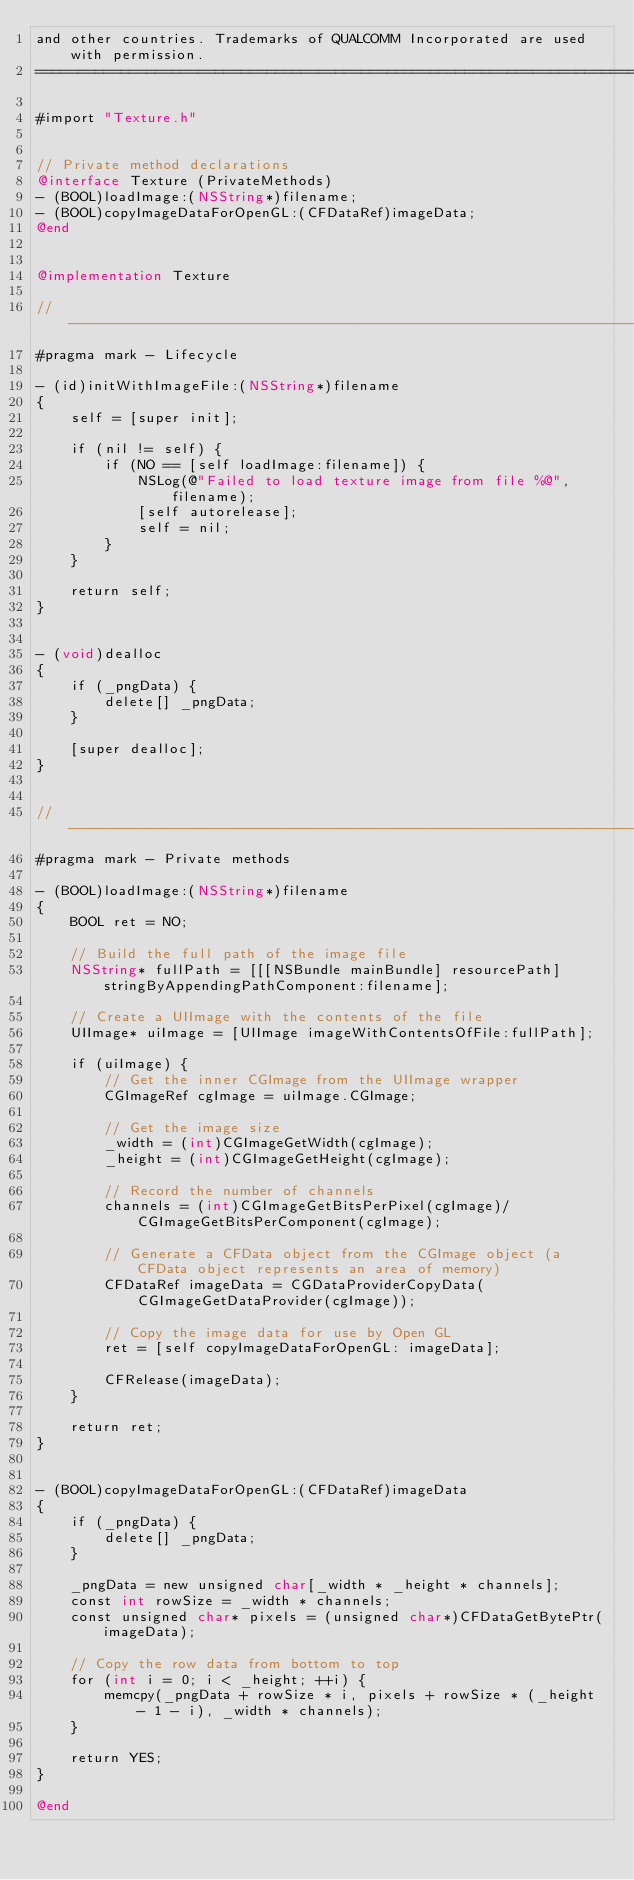<code> <loc_0><loc_0><loc_500><loc_500><_ObjectiveC_>and other countries. Trademarks of QUALCOMM Incorporated are used with permission.
===============================================================================*/

#import "Texture.h"


// Private method declarations
@interface Texture (PrivateMethods)
- (BOOL)loadImage:(NSString*)filename;
- (BOOL)copyImageDataForOpenGL:(CFDataRef)imageData;
@end


@implementation Texture

//------------------------------------------------------------------------------
#pragma mark - Lifecycle

- (id)initWithImageFile:(NSString*)filename
{
    self = [super init];
    
    if (nil != self) {
        if (NO == [self loadImage:filename]) {
            NSLog(@"Failed to load texture image from file %@", filename);
            [self autorelease];
            self = nil;
        }
    }
    
    return self;
}


- (void)dealloc
{
    if (_pngData) {
        delete[] _pngData;
    }
    
    [super dealloc];
}


//------------------------------------------------------------------------------
#pragma mark - Private methods

- (BOOL)loadImage:(NSString*)filename
{
    BOOL ret = NO;
    
    // Build the full path of the image file
    NSString* fullPath = [[[NSBundle mainBundle] resourcePath] stringByAppendingPathComponent:filename];
    
    // Create a UIImage with the contents of the file
    UIImage* uiImage = [UIImage imageWithContentsOfFile:fullPath];
    
    if (uiImage) {
        // Get the inner CGImage from the UIImage wrapper
        CGImageRef cgImage = uiImage.CGImage;
        
        // Get the image size
        _width = (int)CGImageGetWidth(cgImage);
        _height = (int)CGImageGetHeight(cgImage);
        
        // Record the number of channels
        channels = (int)CGImageGetBitsPerPixel(cgImage)/CGImageGetBitsPerComponent(cgImage);
        
        // Generate a CFData object from the CGImage object (a CFData object represents an area of memory)
        CFDataRef imageData = CGDataProviderCopyData(CGImageGetDataProvider(cgImage));
        
        // Copy the image data for use by Open GL
        ret = [self copyImageDataForOpenGL: imageData];
        
        CFRelease(imageData);
    }
    
    return ret;
}


- (BOOL)copyImageDataForOpenGL:(CFDataRef)imageData
{    
    if (_pngData) {
        delete[] _pngData;
    }
    
    _pngData = new unsigned char[_width * _height * channels];
    const int rowSize = _width * channels;
    const unsigned char* pixels = (unsigned char*)CFDataGetBytePtr(imageData);

    // Copy the row data from bottom to top
    for (int i = 0; i < _height; ++i) {
        memcpy(_pngData + rowSize * i, pixels + rowSize * (_height - 1 - i), _width * channels);
    }
    
    return YES;
}

@end
</code> 